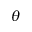<formula> <loc_0><loc_0><loc_500><loc_500>\theta</formula> 